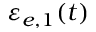<formula> <loc_0><loc_0><loc_500><loc_500>\varepsilon _ { e , 1 } ( t )</formula> 